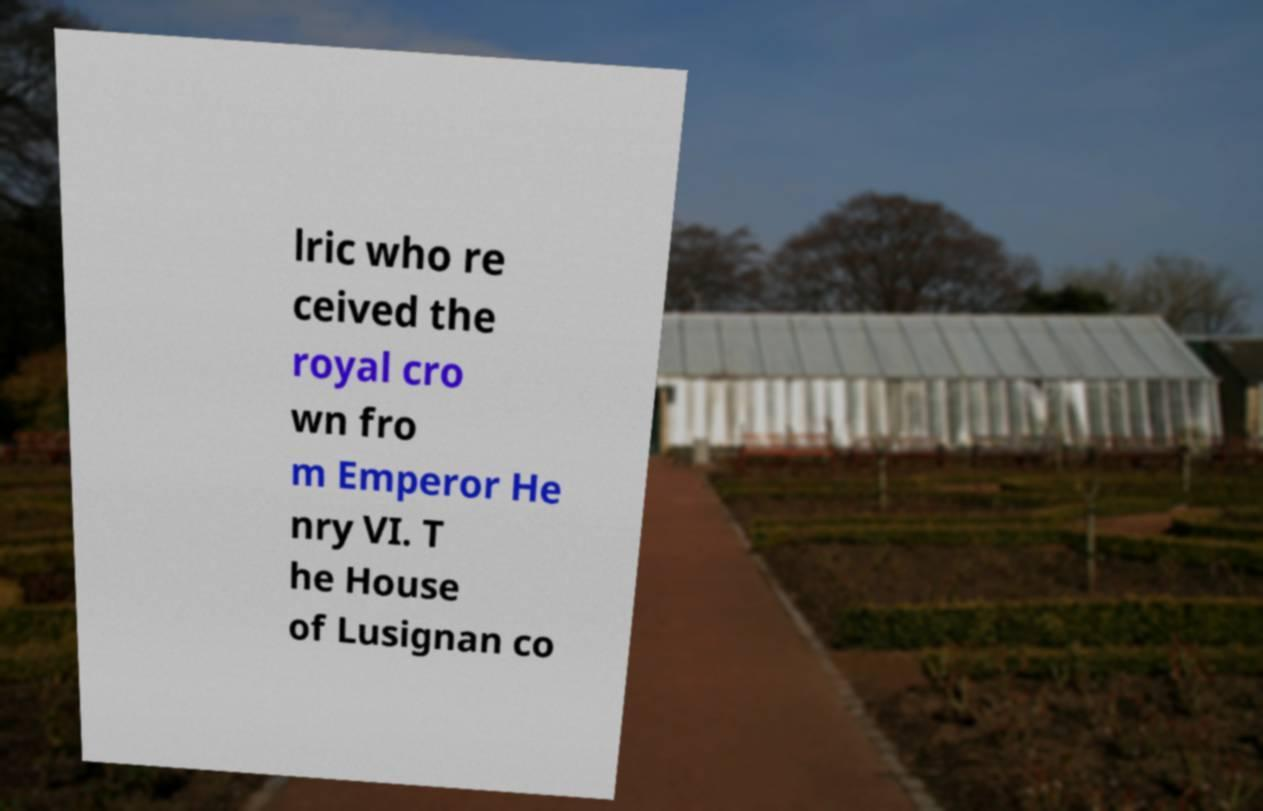For documentation purposes, I need the text within this image transcribed. Could you provide that? lric who re ceived the royal cro wn fro m Emperor He nry VI. T he House of Lusignan co 